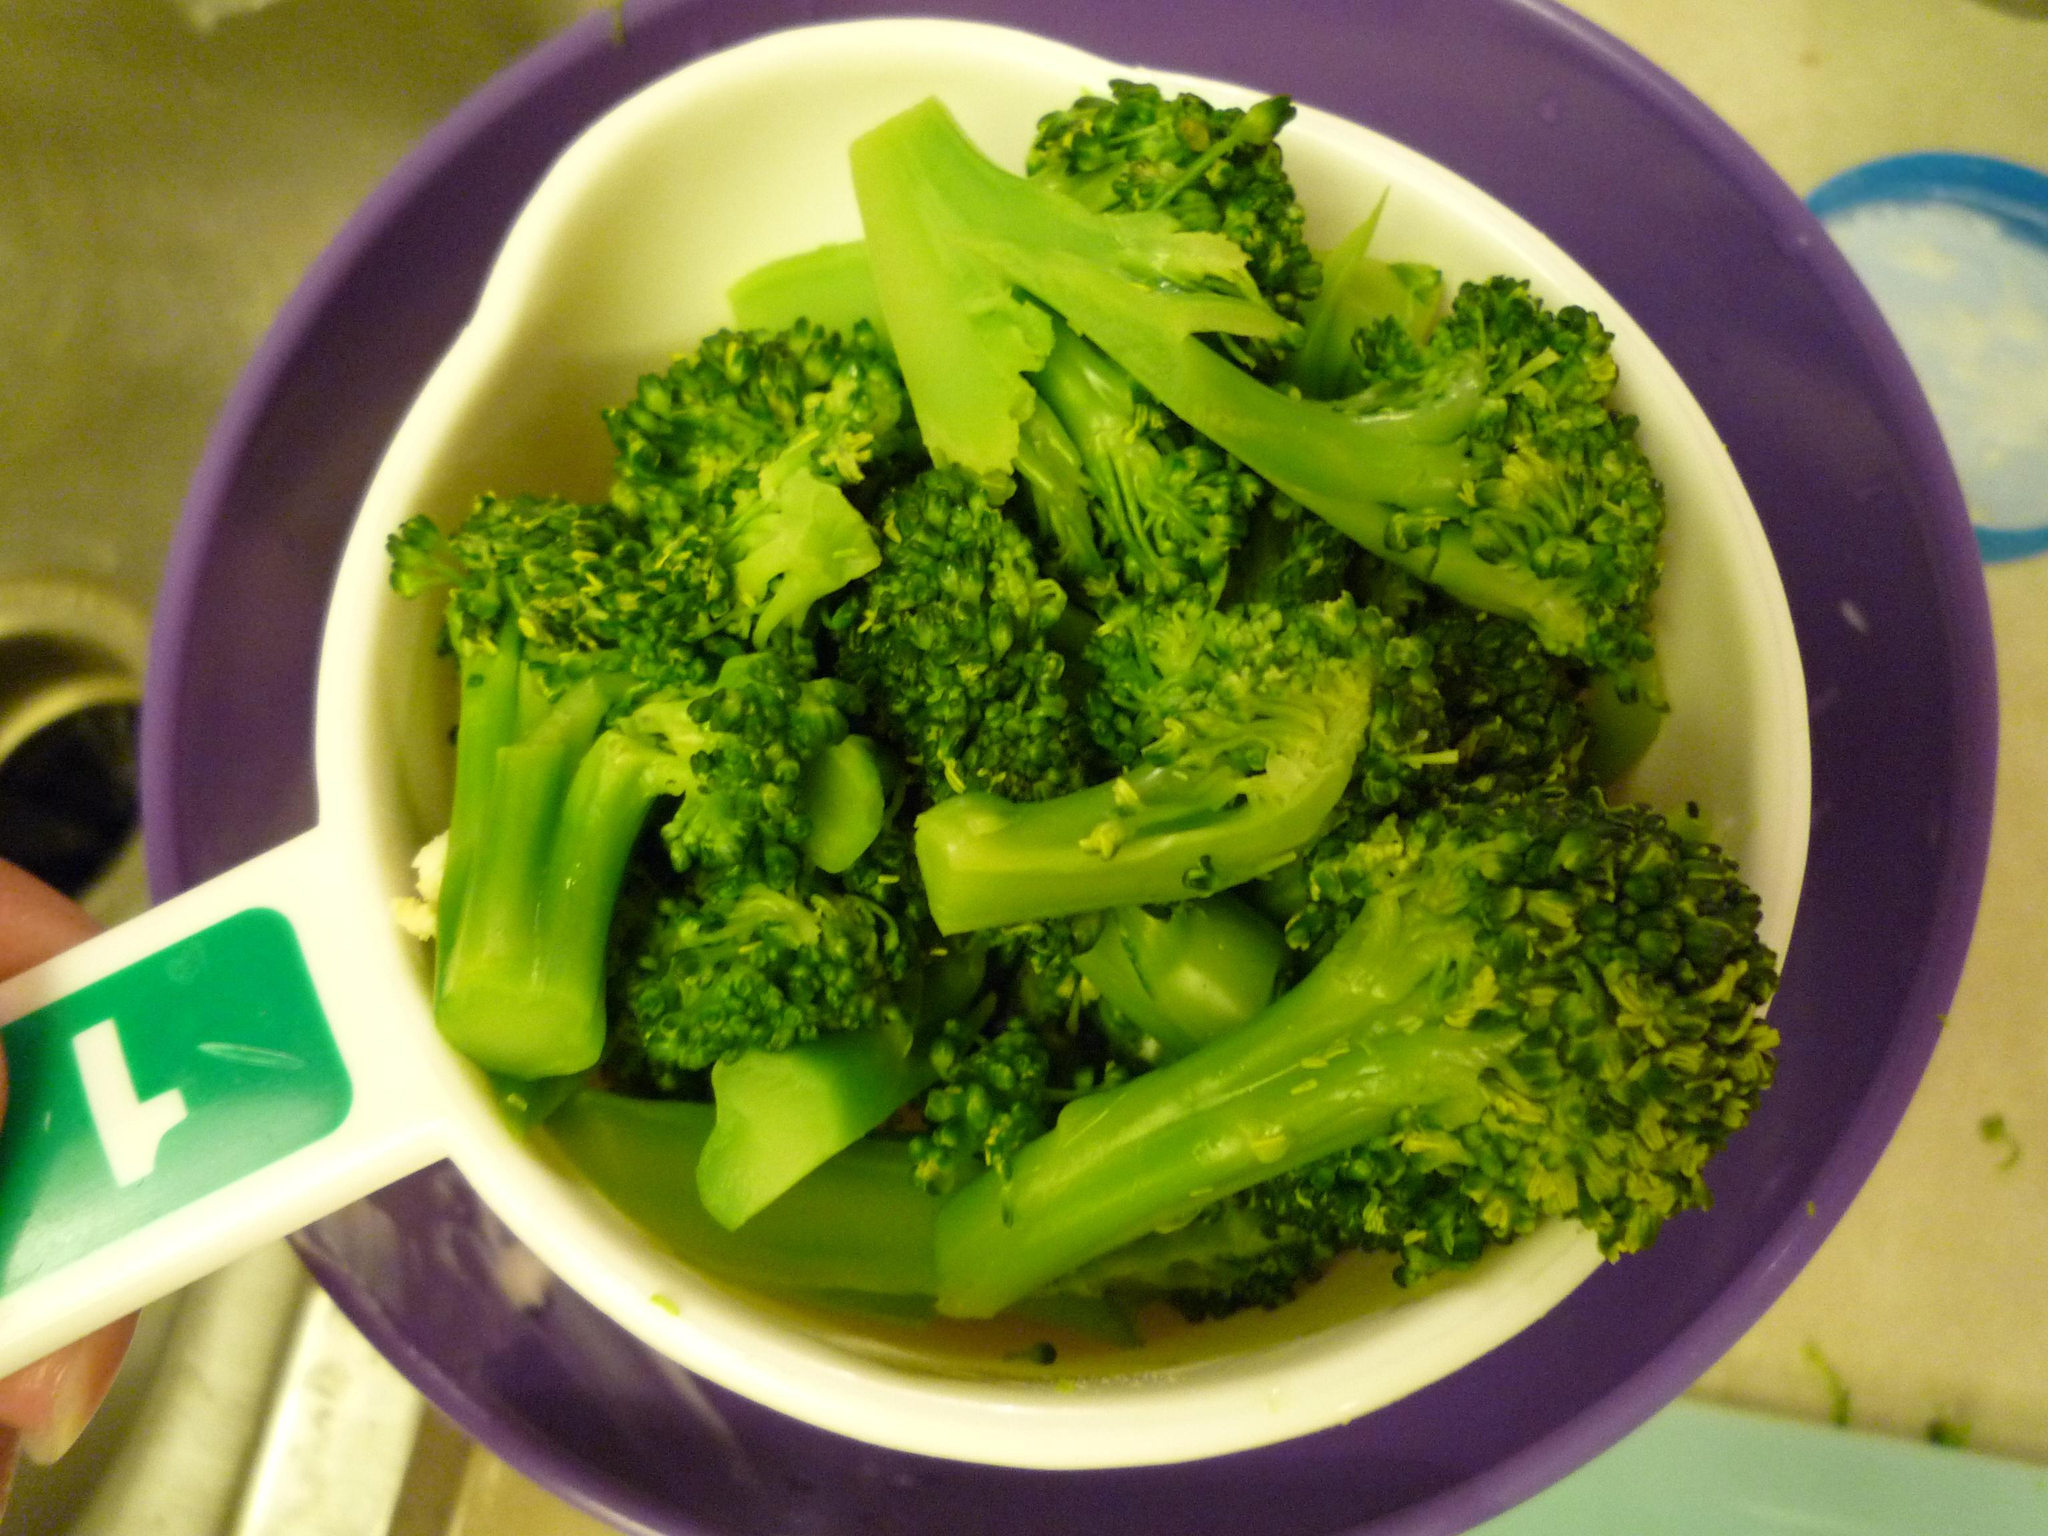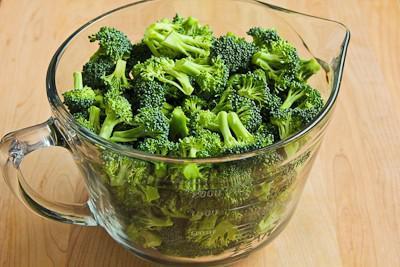The first image is the image on the left, the second image is the image on the right. Considering the images on both sides, is "No dish is visible in the left image." valid? Answer yes or no. No. The first image is the image on the left, the second image is the image on the right. For the images shown, is this caption "An image shows broccoli in a white container with a handle." true? Answer yes or no. Yes. 